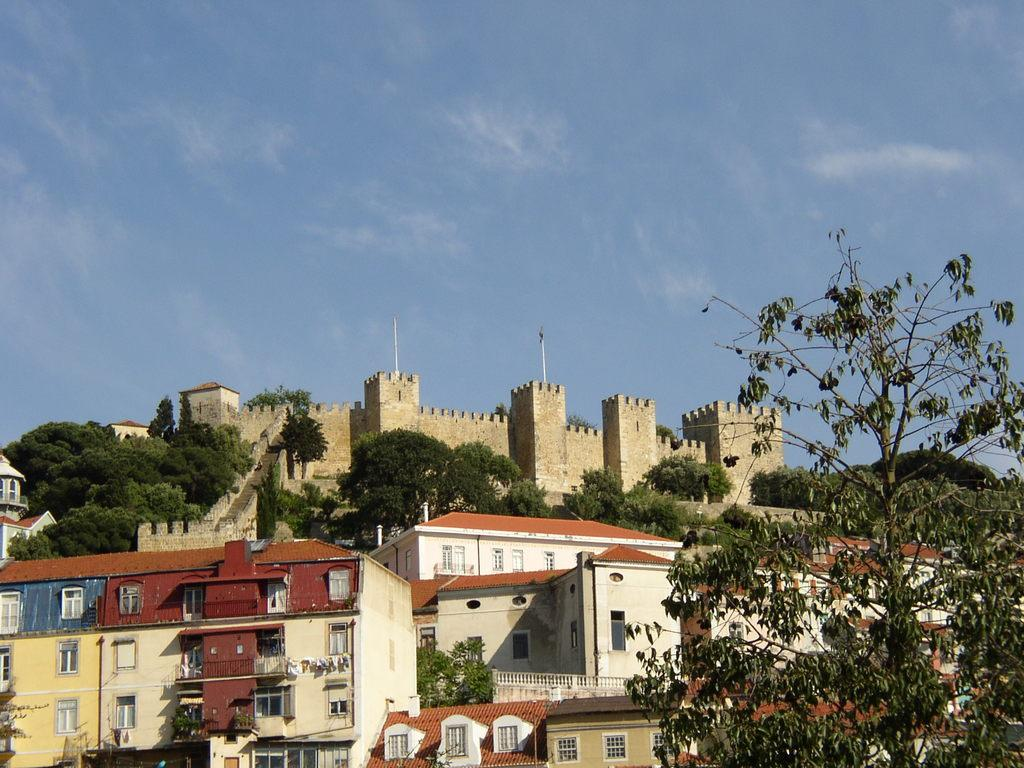What type of structures can be seen in the image? There are buildings in the image. What other natural elements are present in the image? There are trees in the image. Can you describe the elevated structure in the image? There is a fort on a hill above the buildings. What is visible at the top of the image? The sky is visible at the top of the image. What type of skin condition can be seen on the trees in the image? There is no mention of any skin condition on the trees in the image; they appear to be healthy. Can you describe the rabbit playing near the fort in the image? There is no rabbit present in the image; only buildings, trees, and a fort are visible. 